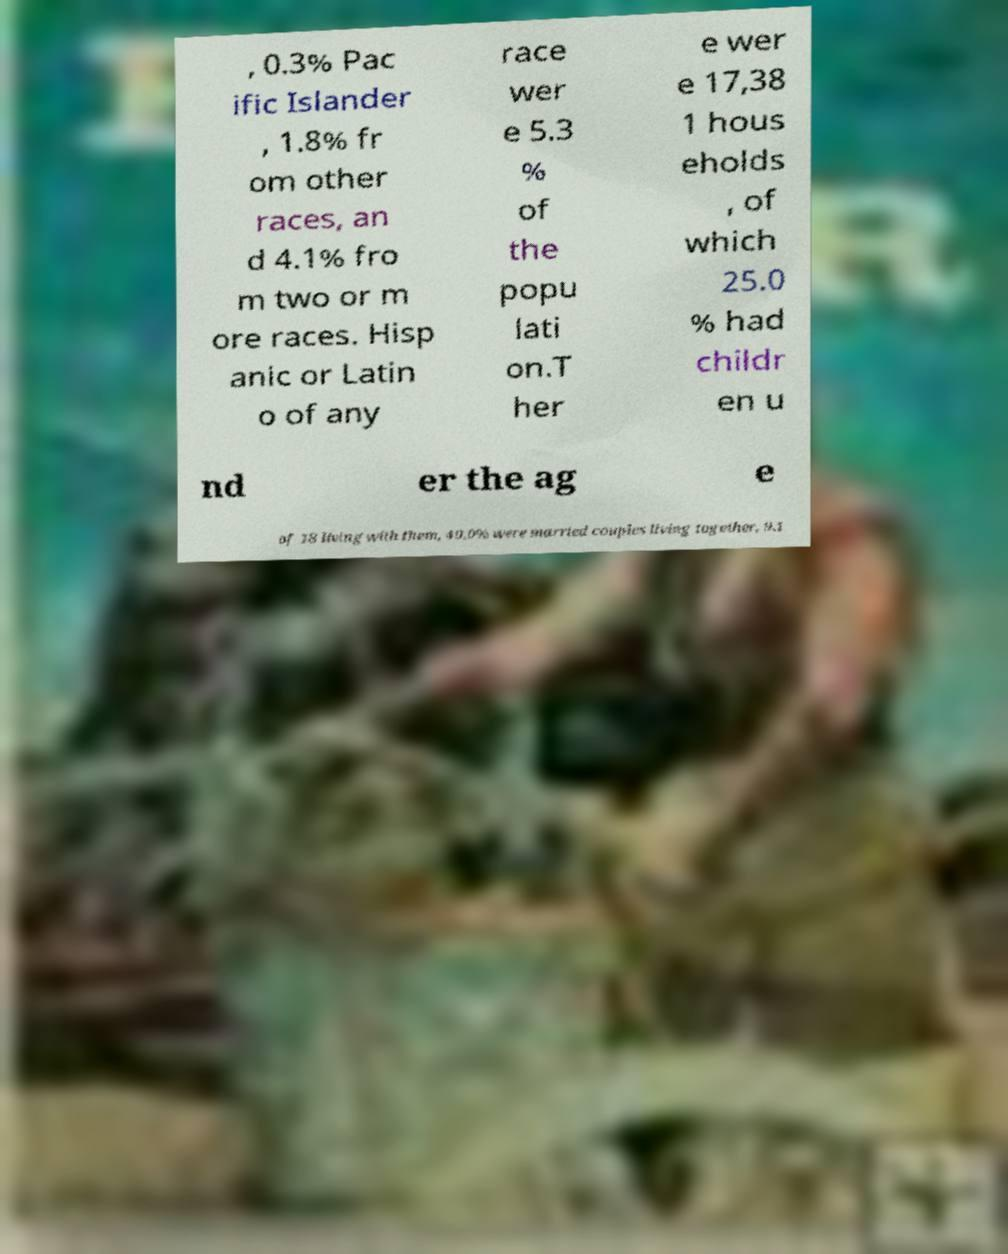For documentation purposes, I need the text within this image transcribed. Could you provide that? , 0.3% Pac ific Islander , 1.8% fr om other races, an d 4.1% fro m two or m ore races. Hisp anic or Latin o of any race wer e 5.3 % of the popu lati on.T her e wer e 17,38 1 hous eholds , of which 25.0 % had childr en u nd er the ag e of 18 living with them, 49.0% were married couples living together, 9.1 